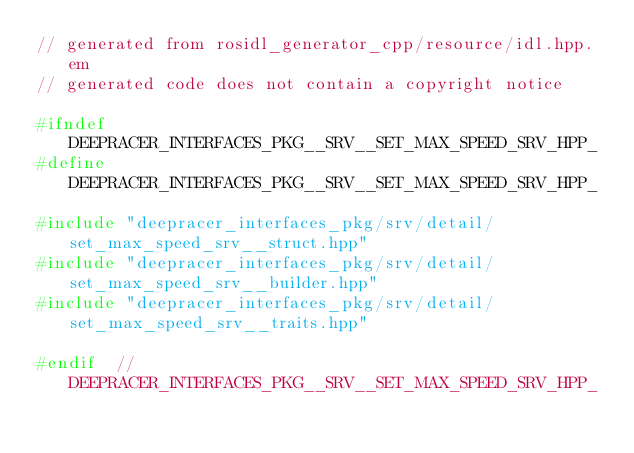<code> <loc_0><loc_0><loc_500><loc_500><_C++_>// generated from rosidl_generator_cpp/resource/idl.hpp.em
// generated code does not contain a copyright notice

#ifndef DEEPRACER_INTERFACES_PKG__SRV__SET_MAX_SPEED_SRV_HPP_
#define DEEPRACER_INTERFACES_PKG__SRV__SET_MAX_SPEED_SRV_HPP_

#include "deepracer_interfaces_pkg/srv/detail/set_max_speed_srv__struct.hpp"
#include "deepracer_interfaces_pkg/srv/detail/set_max_speed_srv__builder.hpp"
#include "deepracer_interfaces_pkg/srv/detail/set_max_speed_srv__traits.hpp"

#endif  // DEEPRACER_INTERFACES_PKG__SRV__SET_MAX_SPEED_SRV_HPP_
</code> 